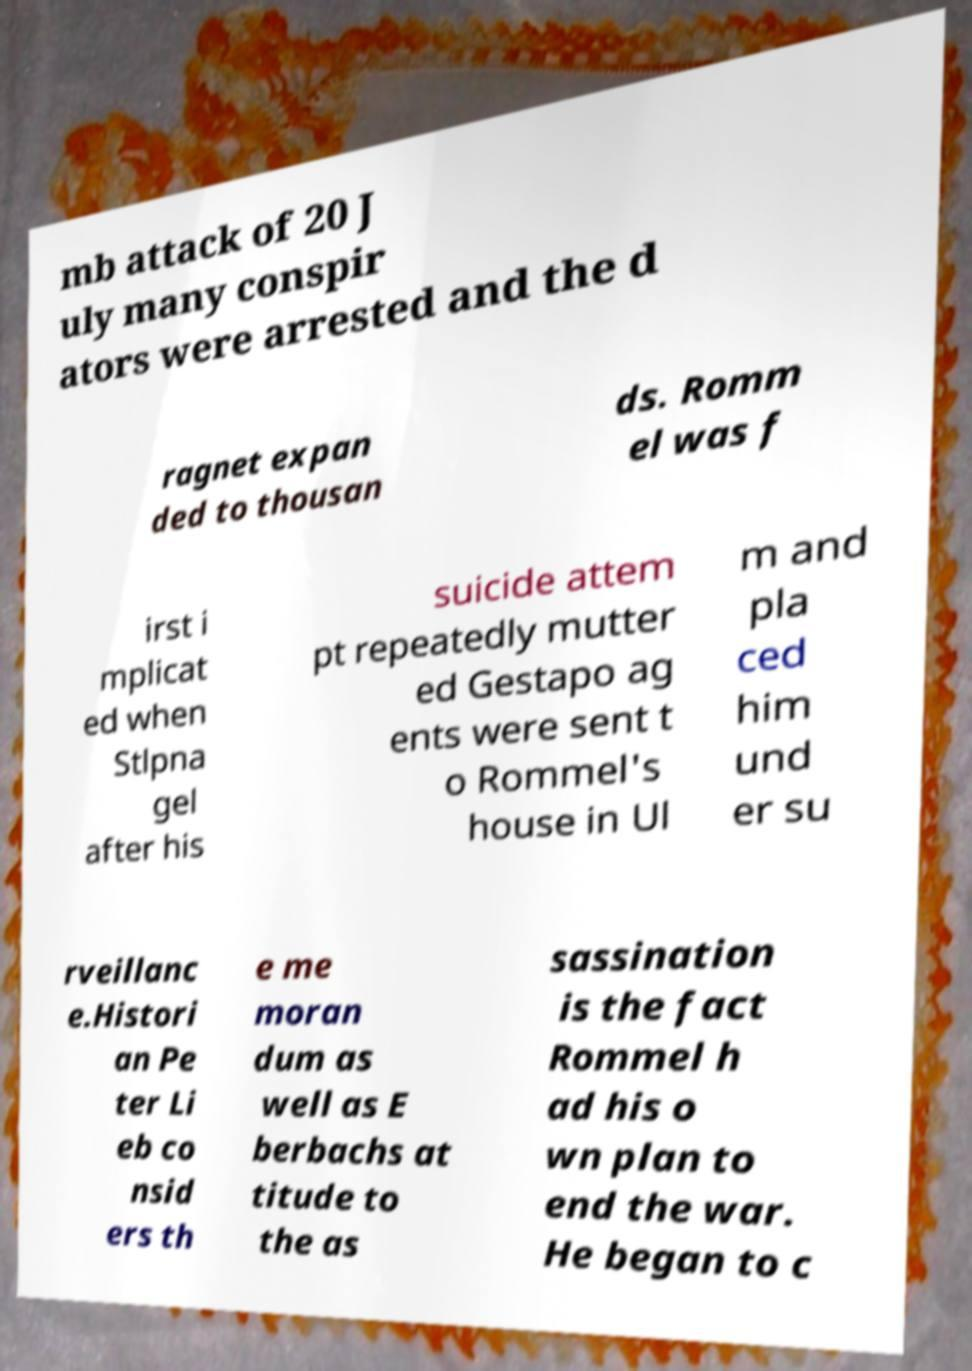Could you extract and type out the text from this image? mb attack of 20 J uly many conspir ators were arrested and the d ragnet expan ded to thousan ds. Romm el was f irst i mplicat ed when Stlpna gel after his suicide attem pt repeatedly mutter ed Gestapo ag ents were sent t o Rommel's house in Ul m and pla ced him und er su rveillanc e.Histori an Pe ter Li eb co nsid ers th e me moran dum as well as E berbachs at titude to the as sassination is the fact Rommel h ad his o wn plan to end the war. He began to c 